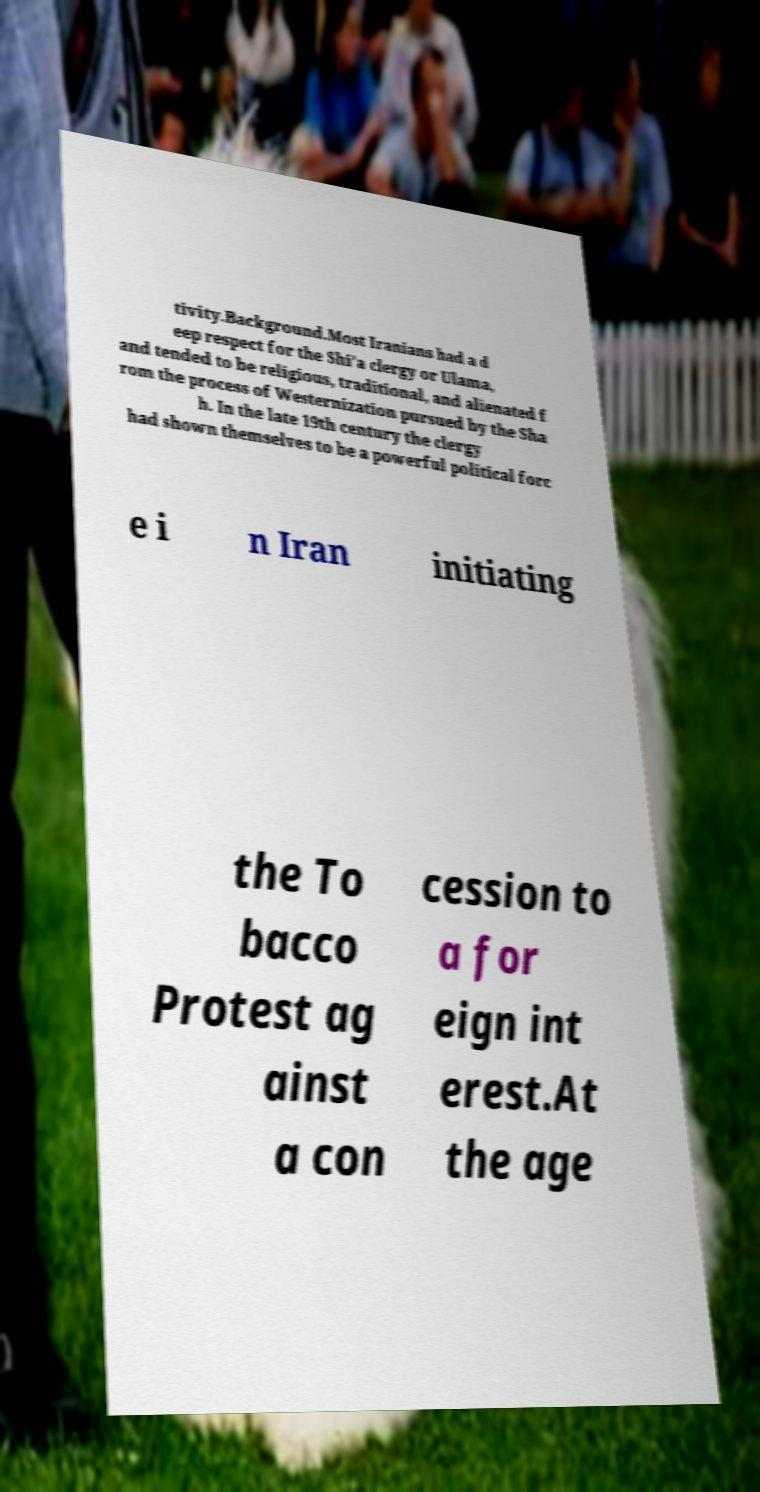There's text embedded in this image that I need extracted. Can you transcribe it verbatim? tivity.Background.Most Iranians had a d eep respect for the Shi'a clergy or Ulama, and tended to be religious, traditional, and alienated f rom the process of Westernization pursued by the Sha h. In the late 19th century the clergy had shown themselves to be a powerful political forc e i n Iran initiating the To bacco Protest ag ainst a con cession to a for eign int erest.At the age 